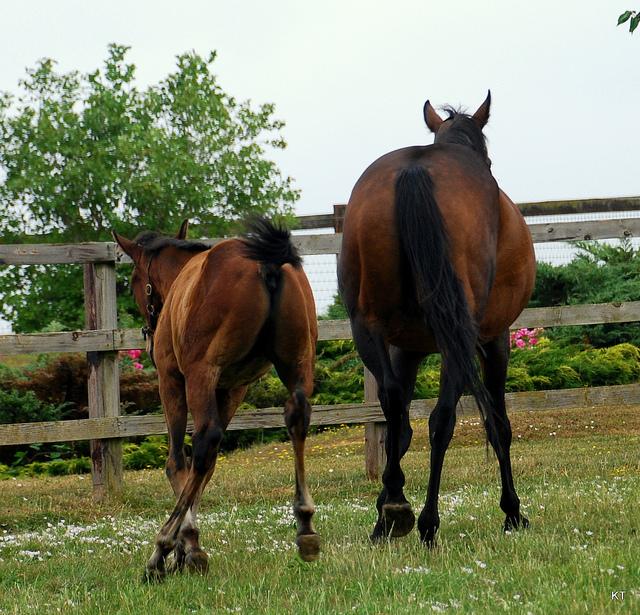What is the fence made of?
Keep it brief. Wood. What is the likely relationship between these animals?
Quick response, please. Mother child. How many horses?
Concise answer only. 2. 